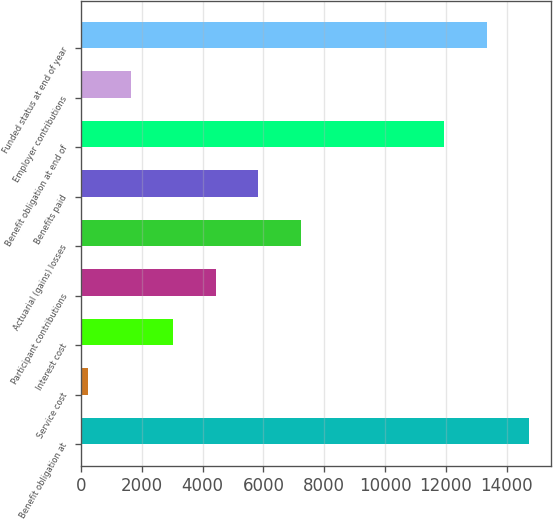Convert chart. <chart><loc_0><loc_0><loc_500><loc_500><bar_chart><fcel>Benefit obligation at<fcel>Service cost<fcel>Interest cost<fcel>Participant contributions<fcel>Actuarial (gains) losses<fcel>Benefits paid<fcel>Benefit obligation at end of<fcel>Employer contributions<fcel>Funded status at end of year<nl><fcel>14732.8<fcel>234<fcel>3030.8<fcel>4429.2<fcel>7226<fcel>5827.6<fcel>11936<fcel>1632.4<fcel>13334.4<nl></chart> 